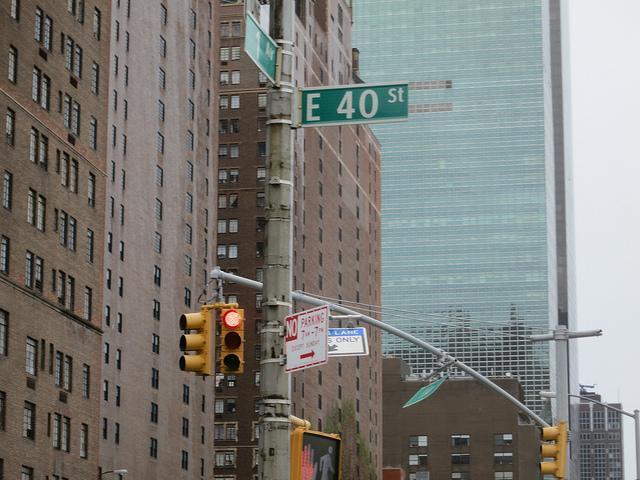How many traffic lights are there?
Give a very brief answer. 2. How many arrows are in this image?
Give a very brief answer. 1. 